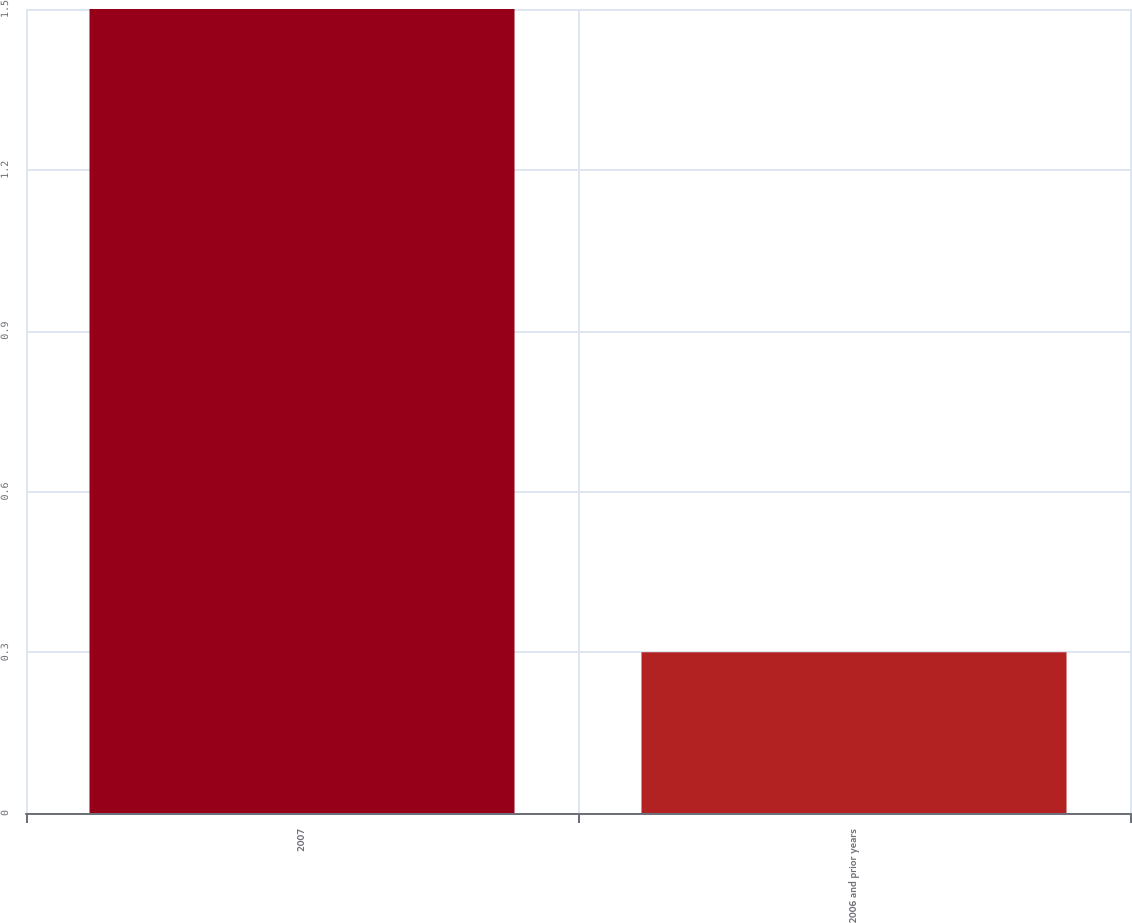Convert chart to OTSL. <chart><loc_0><loc_0><loc_500><loc_500><bar_chart><fcel>2007<fcel>2006 and prior years<nl><fcel>1.5<fcel>0.3<nl></chart> 